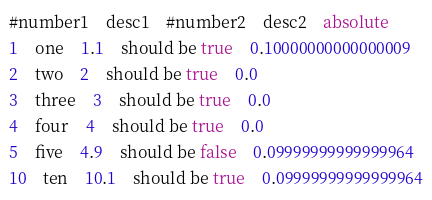<code> <loc_0><loc_0><loc_500><loc_500><_SQL_>#number1	desc1	#number2	desc2	absolute
1	one	1.1	should be true	0.10000000000000009
2	two	2	should be true	0.0
3	three	3	should be true	0.0
4	four	4	should be true	0.0
5	five	4.9	should be false	0.09999999999999964
10	ten	10.1	should be true	0.09999999999999964
</code> 